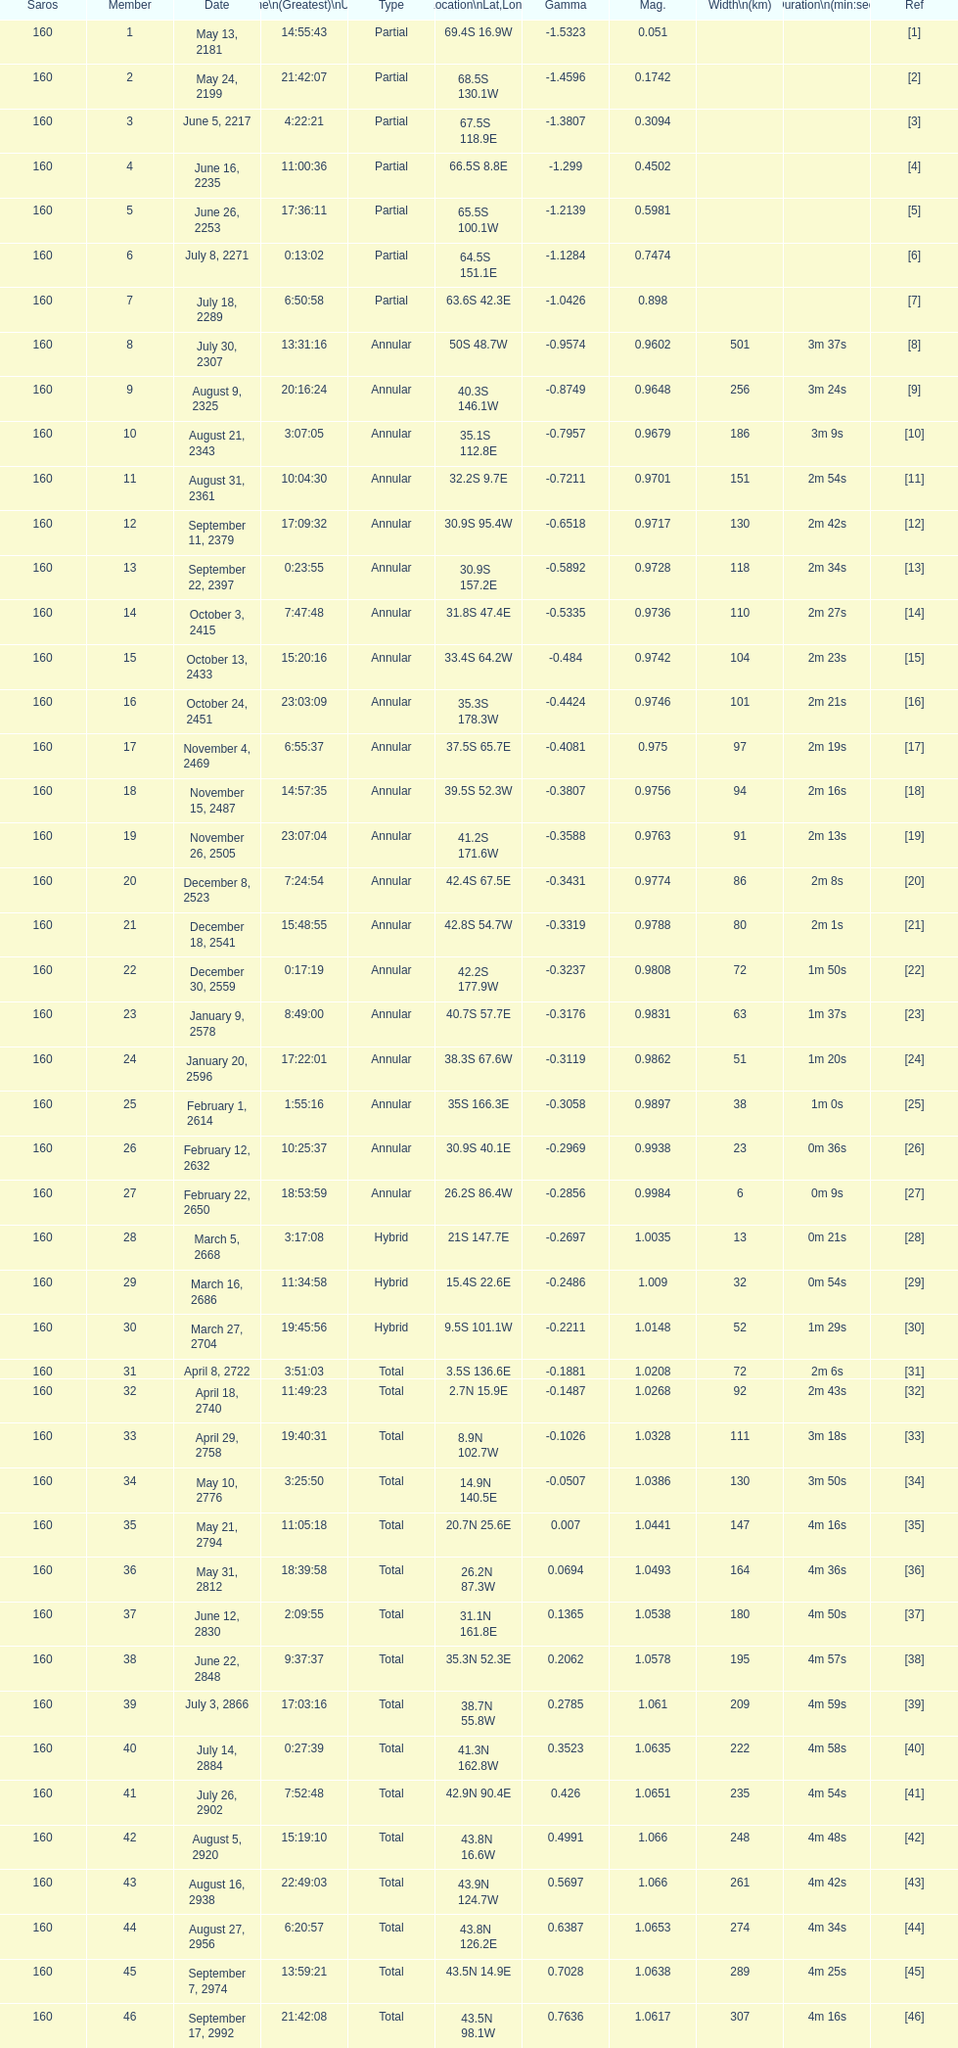Mention one that possesses an equivalent latitude to the one occupied by member 1 13. 